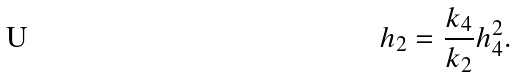Convert formula to latex. <formula><loc_0><loc_0><loc_500><loc_500>h _ { 2 } = \frac { k _ { 4 } } { k _ { 2 } } h _ { 4 } ^ { 2 } .</formula> 